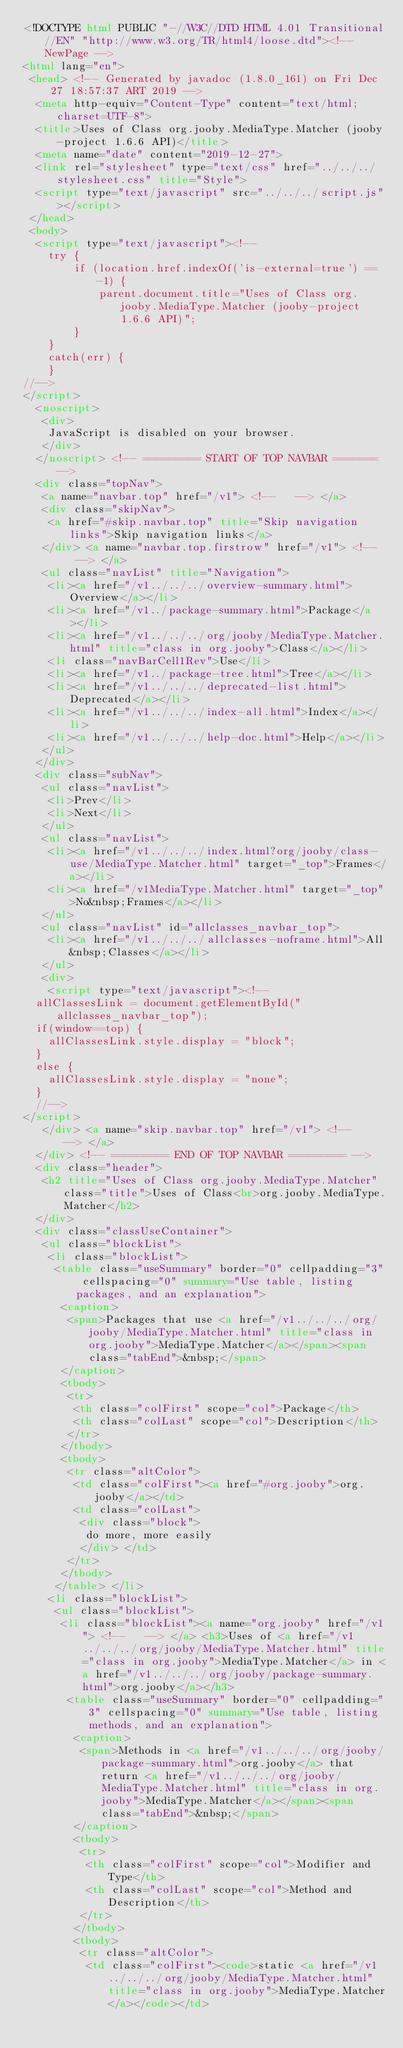Convert code to text. <code><loc_0><loc_0><loc_500><loc_500><_HTML_><!DOCTYPE html PUBLIC "-//W3C//DTD HTML 4.01 Transitional//EN" "http://www.w3.org/TR/html4/loose.dtd"><!-- NewPage -->
<html lang="en"> 
 <head> <!-- Generated by javadoc (1.8.0_161) on Fri Dec 27 18:57:37 ART 2019 --> 
  <meta http-equiv="Content-Type" content="text/html; charset=UTF-8"> 
  <title>Uses of Class org.jooby.MediaType.Matcher (jooby-project 1.6.6 API)</title> 
  <meta name="date" content="2019-12-27"> 
  <link rel="stylesheet" type="text/css" href="../../../stylesheet.css" title="Style"> 
  <script type="text/javascript" src="../../../script.js"></script> 
 </head> 
 <body> 
  <script type="text/javascript"><!--
    try {
        if (location.href.indexOf('is-external=true') == -1) {
            parent.document.title="Uses of Class org.jooby.MediaType.Matcher (jooby-project 1.6.6 API)";
        }
    }
    catch(err) {
    }
//-->
</script> 
  <noscript> 
   <div>
    JavaScript is disabled on your browser.
   </div> 
  </noscript> <!-- ========= START OF TOP NAVBAR ======= --> 
  <div class="topNav">
   <a name="navbar.top" href="/v1"> <!--   --> </a> 
   <div class="skipNav">
    <a href="#skip.navbar.top" title="Skip navigation links">Skip navigation links</a>
   </div> <a name="navbar.top.firstrow" href="/v1"> <!--   --> </a> 
   <ul class="navList" title="Navigation"> 
    <li><a href="/v1../../../overview-summary.html">Overview</a></li> 
    <li><a href="/v1../package-summary.html">Package</a></li> 
    <li><a href="/v1../../../org/jooby/MediaType.Matcher.html" title="class in org.jooby">Class</a></li> 
    <li class="navBarCell1Rev">Use</li> 
    <li><a href="/v1../package-tree.html">Tree</a></li> 
    <li><a href="/v1../../../deprecated-list.html">Deprecated</a></li> 
    <li><a href="/v1../../../index-all.html">Index</a></li> 
    <li><a href="/v1../../../help-doc.html">Help</a></li> 
   </ul> 
  </div> 
  <div class="subNav"> 
   <ul class="navList"> 
    <li>Prev</li> 
    <li>Next</li> 
   </ul> 
   <ul class="navList"> 
    <li><a href="/v1../../../index.html?org/jooby/class-use/MediaType.Matcher.html" target="_top">Frames</a></li> 
    <li><a href="/v1MediaType.Matcher.html" target="_top">No&nbsp;Frames</a></li> 
   </ul> 
   <ul class="navList" id="allclasses_navbar_top"> 
    <li><a href="/v1../../../allclasses-noframe.html">All&nbsp;Classes</a></li> 
   </ul> 
   <div> 
    <script type="text/javascript"><!--
  allClassesLink = document.getElementById("allclasses_navbar_top");
  if(window==top) {
    allClassesLink.style.display = "block";
  }
  else {
    allClassesLink.style.display = "none";
  }
  //-->
</script> 
   </div> <a name="skip.navbar.top" href="/v1"> <!--   --> </a>
  </div> <!-- ========= END OF TOP NAVBAR ========= --> 
  <div class="header"> 
   <h2 title="Uses of Class org.jooby.MediaType.Matcher" class="title">Uses of Class<br>org.jooby.MediaType.Matcher</h2> 
  </div> 
  <div class="classUseContainer"> 
   <ul class="blockList"> 
    <li class="blockList"> 
     <table class="useSummary" border="0" cellpadding="3" cellspacing="0" summary="Use table, listing packages, and an explanation"> 
      <caption>
       <span>Packages that use <a href="/v1../../../org/jooby/MediaType.Matcher.html" title="class in org.jooby">MediaType.Matcher</a></span><span class="tabEnd">&nbsp;</span>
      </caption> 
      <tbody>
       <tr> 
        <th class="colFirst" scope="col">Package</th> 
        <th class="colLast" scope="col">Description</th> 
       </tr> 
      </tbody>
      <tbody> 
       <tr class="altColor"> 
        <td class="colFirst"><a href="#org.jooby">org.jooby</a></td> 
        <td class="colLast"> 
         <div class="block">
          do more, more easily
         </div> </td> 
       </tr> 
      </tbody> 
     </table> </li> 
    <li class="blockList"> 
     <ul class="blockList"> 
      <li class="blockList"><a name="org.jooby" href="/v1"> <!--   --> </a> <h3>Uses of <a href="/v1../../../org/jooby/MediaType.Matcher.html" title="class in org.jooby">MediaType.Matcher</a> in <a href="/v1../../../org/jooby/package-summary.html">org.jooby</a></h3> 
       <table class="useSummary" border="0" cellpadding="3" cellspacing="0" summary="Use table, listing methods, and an explanation"> 
        <caption>
         <span>Methods in <a href="/v1../../../org/jooby/package-summary.html">org.jooby</a> that return <a href="/v1../../../org/jooby/MediaType.Matcher.html" title="class in org.jooby">MediaType.Matcher</a></span><span class="tabEnd">&nbsp;</span>
        </caption> 
        <tbody>
         <tr> 
          <th class="colFirst" scope="col">Modifier and Type</th> 
          <th class="colLast" scope="col">Method and Description</th> 
         </tr> 
        </tbody>
        <tbody> 
         <tr class="altColor"> 
          <td class="colFirst"><code>static <a href="/v1../../../org/jooby/MediaType.Matcher.html" title="class in org.jooby">MediaType.Matcher</a></code></td> </code> 